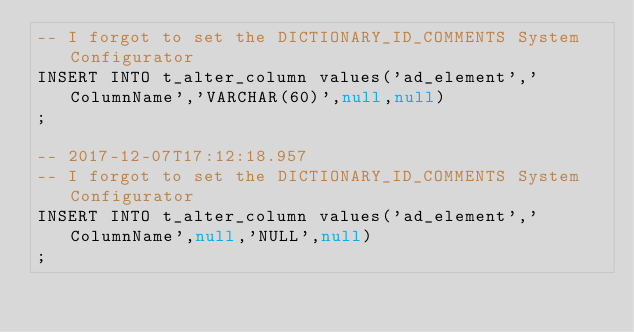<code> <loc_0><loc_0><loc_500><loc_500><_SQL_>-- I forgot to set the DICTIONARY_ID_COMMENTS System Configurator
INSERT INTO t_alter_column values('ad_element','ColumnName','VARCHAR(60)',null,null)
;

-- 2017-12-07T17:12:18.957
-- I forgot to set the DICTIONARY_ID_COMMENTS System Configurator
INSERT INTO t_alter_column values('ad_element','ColumnName',null,'NULL',null)
;

</code> 